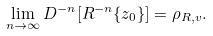<formula> <loc_0><loc_0><loc_500><loc_500>\lim _ { n \to \infty } D ^ { - n } [ R ^ { - n } \{ z _ { 0 } \} ] = \rho _ { R , v } .</formula> 